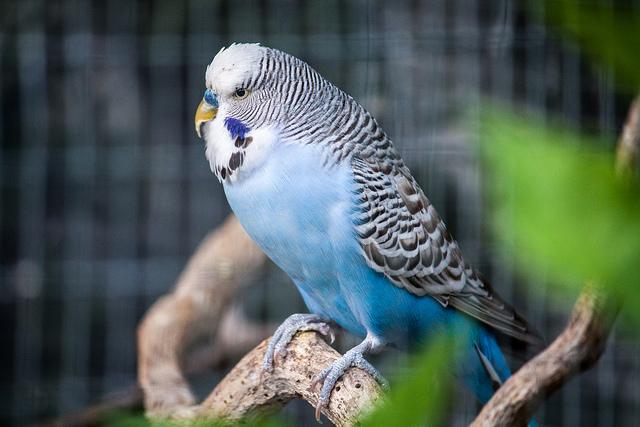Can parrot be taught to speak sentences?
Give a very brief answer. Yes. What is the bird standing on?
Short answer required. Branch. What species is the bird?
Write a very short answer. Parrot. What type of bird is this?
Write a very short answer. Parakeet. 